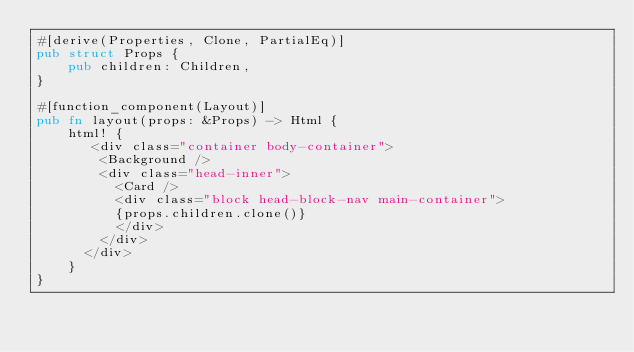Convert code to text. <code><loc_0><loc_0><loc_500><loc_500><_Rust_>#[derive(Properties, Clone, PartialEq)]
pub struct Props {
    pub children: Children,
}

#[function_component(Layout)]
pub fn layout(props: &Props) -> Html {
    html! {
       <div class="container body-container">
        <Background />
        <div class="head-inner">
          <Card />
          <div class="block head-block-nav main-container">
          {props.children.clone()}
          </div>
        </div>
      </div>
    }
}
</code> 